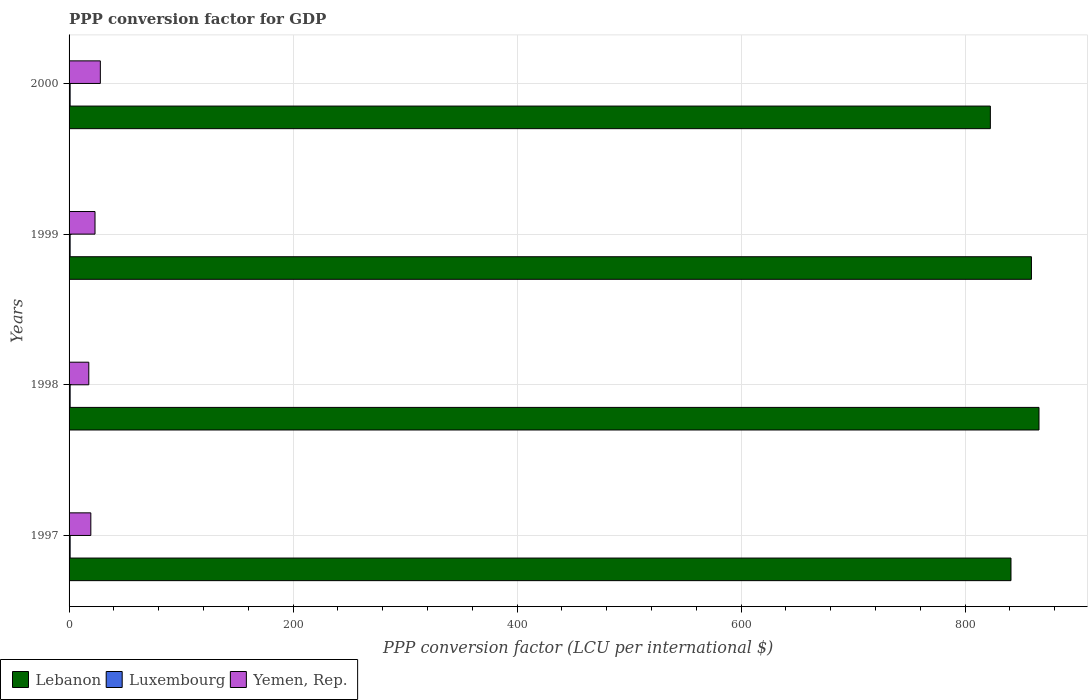How many groups of bars are there?
Provide a succinct answer. 4. Are the number of bars per tick equal to the number of legend labels?
Provide a succinct answer. Yes. How many bars are there on the 1st tick from the bottom?
Ensure brevity in your answer.  3. What is the PPP conversion factor for GDP in Luxembourg in 1999?
Make the answer very short. 0.94. Across all years, what is the maximum PPP conversion factor for GDP in Luxembourg?
Keep it short and to the point. 0.96. Across all years, what is the minimum PPP conversion factor for GDP in Luxembourg?
Offer a terse response. 0.94. What is the total PPP conversion factor for GDP in Yemen, Rep. in the graph?
Your answer should be compact. 88.13. What is the difference between the PPP conversion factor for GDP in Luxembourg in 1999 and that in 2000?
Your answer should be very brief. 0. What is the difference between the PPP conversion factor for GDP in Luxembourg in 1997 and the PPP conversion factor for GDP in Lebanon in 1999?
Give a very brief answer. -858.29. What is the average PPP conversion factor for GDP in Luxembourg per year?
Ensure brevity in your answer.  0.95. In the year 2000, what is the difference between the PPP conversion factor for GDP in Luxembourg and PPP conversion factor for GDP in Yemen, Rep.?
Your answer should be compact. -26.99. In how many years, is the PPP conversion factor for GDP in Yemen, Rep. greater than 320 LCU?
Your answer should be very brief. 0. What is the ratio of the PPP conversion factor for GDP in Yemen, Rep. in 1997 to that in 1998?
Your answer should be compact. 1.1. Is the PPP conversion factor for GDP in Luxembourg in 1998 less than that in 1999?
Make the answer very short. No. Is the difference between the PPP conversion factor for GDP in Luxembourg in 1998 and 2000 greater than the difference between the PPP conversion factor for GDP in Yemen, Rep. in 1998 and 2000?
Your answer should be compact. Yes. What is the difference between the highest and the second highest PPP conversion factor for GDP in Lebanon?
Make the answer very short. 6.75. What is the difference between the highest and the lowest PPP conversion factor for GDP in Luxembourg?
Keep it short and to the point. 0.02. What does the 1st bar from the top in 1998 represents?
Your answer should be compact. Yemen, Rep. What does the 1st bar from the bottom in 1999 represents?
Provide a short and direct response. Lebanon. How many bars are there?
Keep it short and to the point. 12. What is the difference between two consecutive major ticks on the X-axis?
Keep it short and to the point. 200. Does the graph contain any zero values?
Keep it short and to the point. No. How many legend labels are there?
Provide a succinct answer. 3. What is the title of the graph?
Offer a terse response. PPP conversion factor for GDP. What is the label or title of the X-axis?
Offer a terse response. PPP conversion factor (LCU per international $). What is the label or title of the Y-axis?
Your answer should be compact. Years. What is the PPP conversion factor (LCU per international $) of Lebanon in 1997?
Make the answer very short. 840.98. What is the PPP conversion factor (LCU per international $) in Luxembourg in 1997?
Provide a succinct answer. 0.96. What is the PPP conversion factor (LCU per international $) of Yemen, Rep. in 1997?
Ensure brevity in your answer.  19.43. What is the PPP conversion factor (LCU per international $) in Lebanon in 1998?
Your answer should be compact. 865.99. What is the PPP conversion factor (LCU per international $) of Luxembourg in 1998?
Make the answer very short. 0.95. What is the PPP conversion factor (LCU per international $) of Yemen, Rep. in 1998?
Your answer should be compact. 17.62. What is the PPP conversion factor (LCU per international $) of Lebanon in 1999?
Offer a very short reply. 859.25. What is the PPP conversion factor (LCU per international $) of Luxembourg in 1999?
Keep it short and to the point. 0.94. What is the PPP conversion factor (LCU per international $) of Yemen, Rep. in 1999?
Provide a succinct answer. 23.16. What is the PPP conversion factor (LCU per international $) of Lebanon in 2000?
Your answer should be compact. 822.57. What is the PPP conversion factor (LCU per international $) in Luxembourg in 2000?
Your response must be concise. 0.94. What is the PPP conversion factor (LCU per international $) in Yemen, Rep. in 2000?
Your answer should be very brief. 27.93. Across all years, what is the maximum PPP conversion factor (LCU per international $) in Lebanon?
Make the answer very short. 865.99. Across all years, what is the maximum PPP conversion factor (LCU per international $) in Luxembourg?
Your answer should be very brief. 0.96. Across all years, what is the maximum PPP conversion factor (LCU per international $) of Yemen, Rep.?
Provide a succinct answer. 27.93. Across all years, what is the minimum PPP conversion factor (LCU per international $) of Lebanon?
Ensure brevity in your answer.  822.57. Across all years, what is the minimum PPP conversion factor (LCU per international $) in Luxembourg?
Offer a very short reply. 0.94. Across all years, what is the minimum PPP conversion factor (LCU per international $) in Yemen, Rep.?
Ensure brevity in your answer.  17.62. What is the total PPP conversion factor (LCU per international $) in Lebanon in the graph?
Give a very brief answer. 3388.79. What is the total PPP conversion factor (LCU per international $) of Luxembourg in the graph?
Give a very brief answer. 3.79. What is the total PPP conversion factor (LCU per international $) of Yemen, Rep. in the graph?
Offer a very short reply. 88.13. What is the difference between the PPP conversion factor (LCU per international $) in Lebanon in 1997 and that in 1998?
Keep it short and to the point. -25.01. What is the difference between the PPP conversion factor (LCU per international $) in Luxembourg in 1997 and that in 1998?
Provide a succinct answer. 0.01. What is the difference between the PPP conversion factor (LCU per international $) in Yemen, Rep. in 1997 and that in 1998?
Provide a succinct answer. 1.81. What is the difference between the PPP conversion factor (LCU per international $) in Lebanon in 1997 and that in 1999?
Provide a short and direct response. -18.26. What is the difference between the PPP conversion factor (LCU per international $) of Luxembourg in 1997 and that in 1999?
Your answer should be very brief. 0.02. What is the difference between the PPP conversion factor (LCU per international $) in Yemen, Rep. in 1997 and that in 1999?
Offer a very short reply. -3.73. What is the difference between the PPP conversion factor (LCU per international $) in Lebanon in 1997 and that in 2000?
Provide a short and direct response. 18.41. What is the difference between the PPP conversion factor (LCU per international $) of Luxembourg in 1997 and that in 2000?
Give a very brief answer. 0.02. What is the difference between the PPP conversion factor (LCU per international $) of Yemen, Rep. in 1997 and that in 2000?
Your response must be concise. -8.5. What is the difference between the PPP conversion factor (LCU per international $) in Lebanon in 1998 and that in 1999?
Give a very brief answer. 6.75. What is the difference between the PPP conversion factor (LCU per international $) in Luxembourg in 1998 and that in 1999?
Give a very brief answer. 0.01. What is the difference between the PPP conversion factor (LCU per international $) in Yemen, Rep. in 1998 and that in 1999?
Make the answer very short. -5.54. What is the difference between the PPP conversion factor (LCU per international $) of Lebanon in 1998 and that in 2000?
Your answer should be compact. 43.42. What is the difference between the PPP conversion factor (LCU per international $) of Luxembourg in 1998 and that in 2000?
Your response must be concise. 0.01. What is the difference between the PPP conversion factor (LCU per international $) of Yemen, Rep. in 1998 and that in 2000?
Your response must be concise. -10.31. What is the difference between the PPP conversion factor (LCU per international $) in Lebanon in 1999 and that in 2000?
Offer a terse response. 36.68. What is the difference between the PPP conversion factor (LCU per international $) of Luxembourg in 1999 and that in 2000?
Provide a succinct answer. 0. What is the difference between the PPP conversion factor (LCU per international $) of Yemen, Rep. in 1999 and that in 2000?
Provide a succinct answer. -4.77. What is the difference between the PPP conversion factor (LCU per international $) in Lebanon in 1997 and the PPP conversion factor (LCU per international $) in Luxembourg in 1998?
Give a very brief answer. 840.03. What is the difference between the PPP conversion factor (LCU per international $) in Lebanon in 1997 and the PPP conversion factor (LCU per international $) in Yemen, Rep. in 1998?
Keep it short and to the point. 823.37. What is the difference between the PPP conversion factor (LCU per international $) of Luxembourg in 1997 and the PPP conversion factor (LCU per international $) of Yemen, Rep. in 1998?
Your answer should be very brief. -16.66. What is the difference between the PPP conversion factor (LCU per international $) of Lebanon in 1997 and the PPP conversion factor (LCU per international $) of Luxembourg in 1999?
Provide a short and direct response. 840.04. What is the difference between the PPP conversion factor (LCU per international $) of Lebanon in 1997 and the PPP conversion factor (LCU per international $) of Yemen, Rep. in 1999?
Your response must be concise. 817.82. What is the difference between the PPP conversion factor (LCU per international $) of Luxembourg in 1997 and the PPP conversion factor (LCU per international $) of Yemen, Rep. in 1999?
Provide a succinct answer. -22.2. What is the difference between the PPP conversion factor (LCU per international $) of Lebanon in 1997 and the PPP conversion factor (LCU per international $) of Luxembourg in 2000?
Your response must be concise. 840.04. What is the difference between the PPP conversion factor (LCU per international $) in Lebanon in 1997 and the PPP conversion factor (LCU per international $) in Yemen, Rep. in 2000?
Offer a terse response. 813.05. What is the difference between the PPP conversion factor (LCU per international $) in Luxembourg in 1997 and the PPP conversion factor (LCU per international $) in Yemen, Rep. in 2000?
Your answer should be very brief. -26.97. What is the difference between the PPP conversion factor (LCU per international $) in Lebanon in 1998 and the PPP conversion factor (LCU per international $) in Luxembourg in 1999?
Give a very brief answer. 865.05. What is the difference between the PPP conversion factor (LCU per international $) of Lebanon in 1998 and the PPP conversion factor (LCU per international $) of Yemen, Rep. in 1999?
Your response must be concise. 842.83. What is the difference between the PPP conversion factor (LCU per international $) of Luxembourg in 1998 and the PPP conversion factor (LCU per international $) of Yemen, Rep. in 1999?
Your response must be concise. -22.21. What is the difference between the PPP conversion factor (LCU per international $) of Lebanon in 1998 and the PPP conversion factor (LCU per international $) of Luxembourg in 2000?
Keep it short and to the point. 865.05. What is the difference between the PPP conversion factor (LCU per international $) in Lebanon in 1998 and the PPP conversion factor (LCU per international $) in Yemen, Rep. in 2000?
Offer a terse response. 838.06. What is the difference between the PPP conversion factor (LCU per international $) in Luxembourg in 1998 and the PPP conversion factor (LCU per international $) in Yemen, Rep. in 2000?
Make the answer very short. -26.98. What is the difference between the PPP conversion factor (LCU per international $) in Lebanon in 1999 and the PPP conversion factor (LCU per international $) in Luxembourg in 2000?
Provide a short and direct response. 858.31. What is the difference between the PPP conversion factor (LCU per international $) of Lebanon in 1999 and the PPP conversion factor (LCU per international $) of Yemen, Rep. in 2000?
Provide a short and direct response. 831.32. What is the difference between the PPP conversion factor (LCU per international $) of Luxembourg in 1999 and the PPP conversion factor (LCU per international $) of Yemen, Rep. in 2000?
Provide a short and direct response. -26.99. What is the average PPP conversion factor (LCU per international $) in Lebanon per year?
Your answer should be very brief. 847.2. What is the average PPP conversion factor (LCU per international $) in Luxembourg per year?
Provide a succinct answer. 0.95. What is the average PPP conversion factor (LCU per international $) of Yemen, Rep. per year?
Provide a short and direct response. 22.03. In the year 1997, what is the difference between the PPP conversion factor (LCU per international $) in Lebanon and PPP conversion factor (LCU per international $) in Luxembourg?
Provide a succinct answer. 840.02. In the year 1997, what is the difference between the PPP conversion factor (LCU per international $) of Lebanon and PPP conversion factor (LCU per international $) of Yemen, Rep.?
Make the answer very short. 821.55. In the year 1997, what is the difference between the PPP conversion factor (LCU per international $) of Luxembourg and PPP conversion factor (LCU per international $) of Yemen, Rep.?
Make the answer very short. -18.47. In the year 1998, what is the difference between the PPP conversion factor (LCU per international $) in Lebanon and PPP conversion factor (LCU per international $) in Luxembourg?
Offer a terse response. 865.04. In the year 1998, what is the difference between the PPP conversion factor (LCU per international $) in Lebanon and PPP conversion factor (LCU per international $) in Yemen, Rep.?
Provide a short and direct response. 848.37. In the year 1998, what is the difference between the PPP conversion factor (LCU per international $) in Luxembourg and PPP conversion factor (LCU per international $) in Yemen, Rep.?
Provide a succinct answer. -16.67. In the year 1999, what is the difference between the PPP conversion factor (LCU per international $) of Lebanon and PPP conversion factor (LCU per international $) of Luxembourg?
Provide a succinct answer. 858.3. In the year 1999, what is the difference between the PPP conversion factor (LCU per international $) in Lebanon and PPP conversion factor (LCU per international $) in Yemen, Rep.?
Offer a terse response. 836.09. In the year 1999, what is the difference between the PPP conversion factor (LCU per international $) of Luxembourg and PPP conversion factor (LCU per international $) of Yemen, Rep.?
Make the answer very short. -22.22. In the year 2000, what is the difference between the PPP conversion factor (LCU per international $) of Lebanon and PPP conversion factor (LCU per international $) of Luxembourg?
Provide a succinct answer. 821.63. In the year 2000, what is the difference between the PPP conversion factor (LCU per international $) in Lebanon and PPP conversion factor (LCU per international $) in Yemen, Rep.?
Your answer should be compact. 794.64. In the year 2000, what is the difference between the PPP conversion factor (LCU per international $) in Luxembourg and PPP conversion factor (LCU per international $) in Yemen, Rep.?
Offer a very short reply. -26.99. What is the ratio of the PPP conversion factor (LCU per international $) of Lebanon in 1997 to that in 1998?
Your answer should be compact. 0.97. What is the ratio of the PPP conversion factor (LCU per international $) in Luxembourg in 1997 to that in 1998?
Offer a terse response. 1.01. What is the ratio of the PPP conversion factor (LCU per international $) in Yemen, Rep. in 1997 to that in 1998?
Make the answer very short. 1.1. What is the ratio of the PPP conversion factor (LCU per international $) of Lebanon in 1997 to that in 1999?
Make the answer very short. 0.98. What is the ratio of the PPP conversion factor (LCU per international $) of Luxembourg in 1997 to that in 1999?
Make the answer very short. 1.02. What is the ratio of the PPP conversion factor (LCU per international $) in Yemen, Rep. in 1997 to that in 1999?
Give a very brief answer. 0.84. What is the ratio of the PPP conversion factor (LCU per international $) in Lebanon in 1997 to that in 2000?
Offer a very short reply. 1.02. What is the ratio of the PPP conversion factor (LCU per international $) of Luxembourg in 1997 to that in 2000?
Give a very brief answer. 1.02. What is the ratio of the PPP conversion factor (LCU per international $) in Yemen, Rep. in 1997 to that in 2000?
Ensure brevity in your answer.  0.7. What is the ratio of the PPP conversion factor (LCU per international $) in Lebanon in 1998 to that in 1999?
Your response must be concise. 1.01. What is the ratio of the PPP conversion factor (LCU per international $) of Luxembourg in 1998 to that in 1999?
Your answer should be compact. 1.01. What is the ratio of the PPP conversion factor (LCU per international $) in Yemen, Rep. in 1998 to that in 1999?
Offer a terse response. 0.76. What is the ratio of the PPP conversion factor (LCU per international $) in Lebanon in 1998 to that in 2000?
Offer a terse response. 1.05. What is the ratio of the PPP conversion factor (LCU per international $) of Luxembourg in 1998 to that in 2000?
Provide a short and direct response. 1.01. What is the ratio of the PPP conversion factor (LCU per international $) of Yemen, Rep. in 1998 to that in 2000?
Your response must be concise. 0.63. What is the ratio of the PPP conversion factor (LCU per international $) of Lebanon in 1999 to that in 2000?
Make the answer very short. 1.04. What is the ratio of the PPP conversion factor (LCU per international $) in Yemen, Rep. in 1999 to that in 2000?
Provide a succinct answer. 0.83. What is the difference between the highest and the second highest PPP conversion factor (LCU per international $) of Lebanon?
Provide a succinct answer. 6.75. What is the difference between the highest and the second highest PPP conversion factor (LCU per international $) in Luxembourg?
Ensure brevity in your answer.  0.01. What is the difference between the highest and the second highest PPP conversion factor (LCU per international $) in Yemen, Rep.?
Ensure brevity in your answer.  4.77. What is the difference between the highest and the lowest PPP conversion factor (LCU per international $) in Lebanon?
Your answer should be compact. 43.42. What is the difference between the highest and the lowest PPP conversion factor (LCU per international $) in Luxembourg?
Provide a succinct answer. 0.02. What is the difference between the highest and the lowest PPP conversion factor (LCU per international $) of Yemen, Rep.?
Keep it short and to the point. 10.31. 